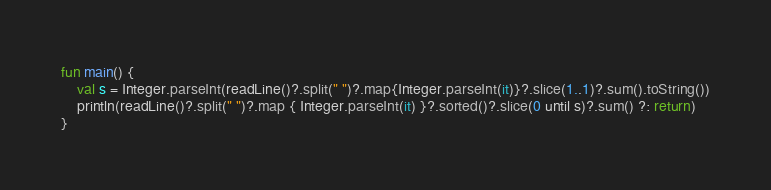Convert code to text. <code><loc_0><loc_0><loc_500><loc_500><_Kotlin_>fun main() {
    val s = Integer.parseInt(readLine()?.split(" ")?.map{Integer.parseInt(it)}?.slice(1..1)?.sum().toString())
    println(readLine()?.split(" ")?.map { Integer.parseInt(it) }?.sorted()?.slice(0 until s)?.sum() ?: return)
}</code> 